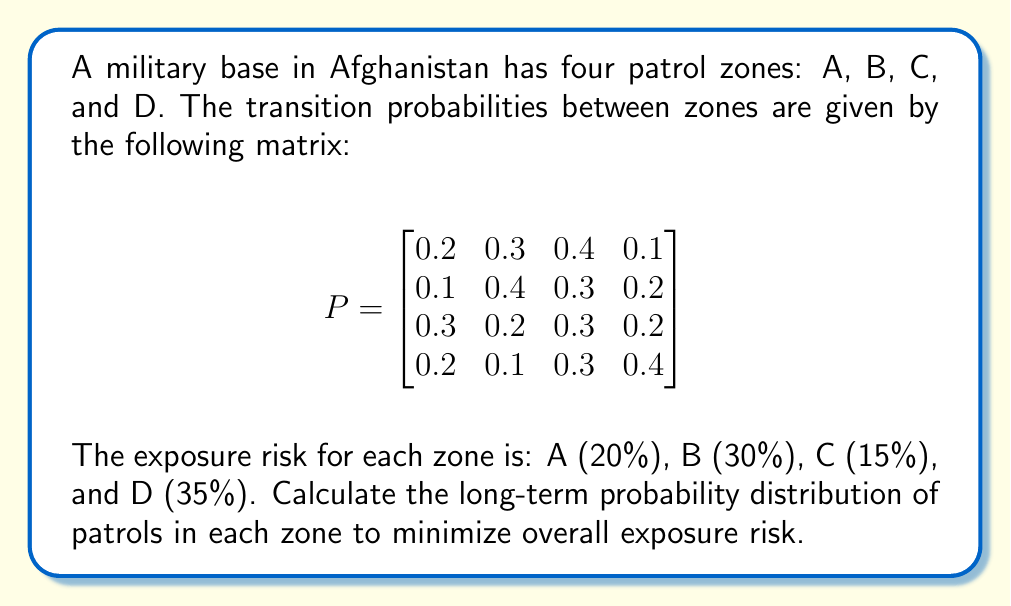Solve this math problem. To solve this problem, we'll follow these steps:

1) First, we need to find the stationary distribution of the Markov chain. This distribution, let's call it $\pi$, satisfies the equation:

   $$\pi P = \pi$$

   where $P$ is the transition matrix.

2) We can solve this equation along with the condition that the probabilities sum to 1:

   $$\pi_A + \pi_B + \pi_C + \pi_D = 1$$

3) This gives us the following system of equations:

   $$\begin{align}
   0.2\pi_A + 0.1\pi_B + 0.3\pi_C + 0.2\pi_D &= \pi_A \\
   0.3\pi_A + 0.4\pi_B + 0.2\pi_C + 0.1\pi_D &= \pi_B \\
   0.4\pi_A + 0.3\pi_B + 0.3\pi_C + 0.3\pi_D &= \pi_C \\
   0.1\pi_A + 0.2\pi_B + 0.2\pi_C + 0.4\pi_D &= \pi_D \\
   \pi_A + \pi_B + \pi_C + \pi_D &= 1
   \end{align}$$

4) Solving this system (using a computer algebra system or numerical methods), we get:

   $$\pi \approx (0.2105, 0.2632, 0.3158, 0.2105)$$

5) Now, we need to calculate the overall exposure risk. This is the dot product of the stationary distribution and the risk vector:

   $$\text{Risk} = 0.2105 \cdot 0.20 + 0.2632 \cdot 0.30 + 0.3158 \cdot 0.15 + 0.2105 \cdot 0.35$$

6) Calculating this:

   $$\text{Risk} = 0.0421 + 0.0790 + 0.0474 + 0.0737 = 0.2422 = 24.22\%$$

Therefore, the long-term probability distribution that minimizes overall exposure risk is approximately (0.2105, 0.2632, 0.3158, 0.2105), resulting in an overall risk of about 24.22%.
Answer: $(0.2105, 0.2632, 0.3158, 0.2105)$; 24.22% risk 